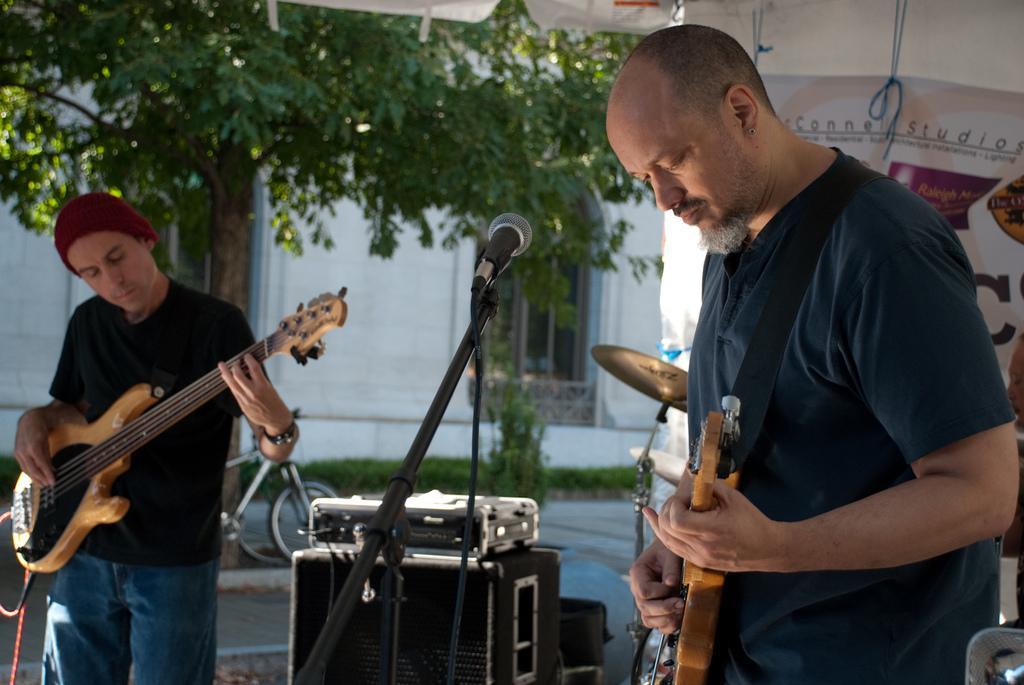How would you summarize this image in a sentence or two? In this image we can see these two persons are holding a guitar in their hands and playing it. There is a mic in front of the of the person wearing blue t shirt. In the background we can see drums, speaker box, banner, trees and building. 